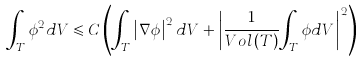Convert formula to latex. <formula><loc_0><loc_0><loc_500><loc_500>\int _ { T } { \phi ^ { 2 } d V \leqslant C } \left ( { \int _ { T } { \left | { \nabla \phi } \right | ^ { 2 } d V } + \left | \frac { 1 } { V o l \left ( T \right ) } { \int _ { T } { \phi d V } } \right | ^ { 2 } } \right )</formula> 